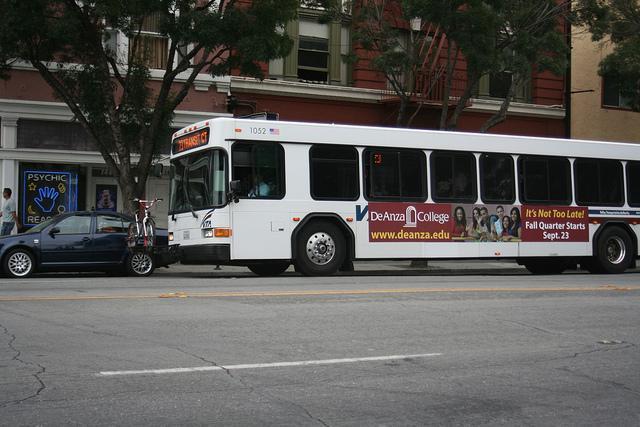How many elephants are there?
Give a very brief answer. 0. 